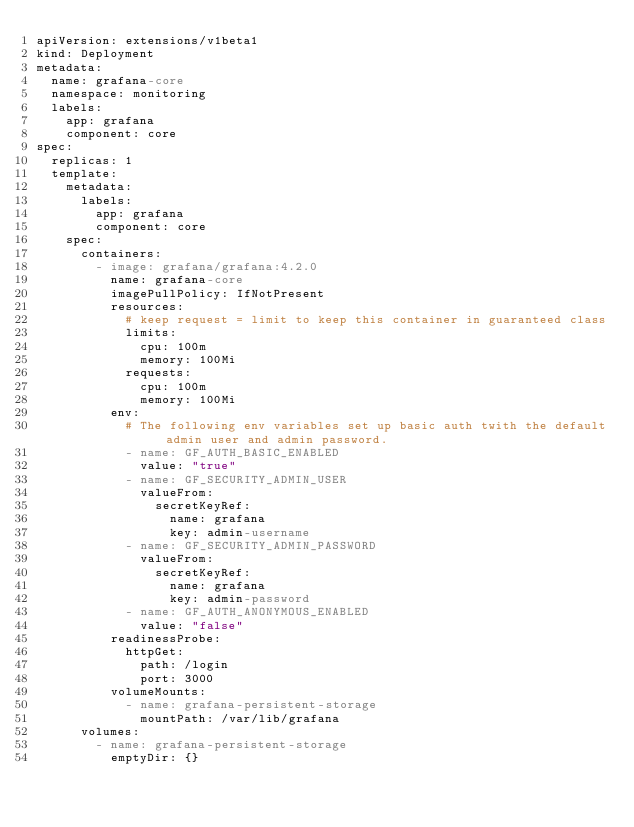Convert code to text. <code><loc_0><loc_0><loc_500><loc_500><_YAML_>apiVersion: extensions/v1beta1
kind: Deployment
metadata:
  name: grafana-core
  namespace: monitoring
  labels:
    app: grafana
    component: core
spec:
  replicas: 1
  template:
    metadata:
      labels:
        app: grafana
        component: core
    spec:
      containers:
        - image: grafana/grafana:4.2.0
          name: grafana-core
          imagePullPolicy: IfNotPresent
          resources:
            # keep request = limit to keep this container in guaranteed class
            limits:
              cpu: 100m
              memory: 100Mi
            requests:
              cpu: 100m
              memory: 100Mi
          env:
            # The following env variables set up basic auth twith the default admin user and admin password.
            - name: GF_AUTH_BASIC_ENABLED
              value: "true"
            - name: GF_SECURITY_ADMIN_USER
              valueFrom:
                secretKeyRef:
                  name: grafana
                  key: admin-username
            - name: GF_SECURITY_ADMIN_PASSWORD
              valueFrom:
                secretKeyRef:
                  name: grafana
                  key: admin-password
            - name: GF_AUTH_ANONYMOUS_ENABLED
              value: "false"
          readinessProbe:
            httpGet:
              path: /login
              port: 3000
          volumeMounts:
            - name: grafana-persistent-storage
              mountPath: /var/lib/grafana
      volumes:
        - name: grafana-persistent-storage
          emptyDir: {}
</code> 